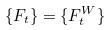<formula> <loc_0><loc_0><loc_500><loc_500>\{ F _ { t } \} = \{ F _ { t } ^ { W } \}</formula> 